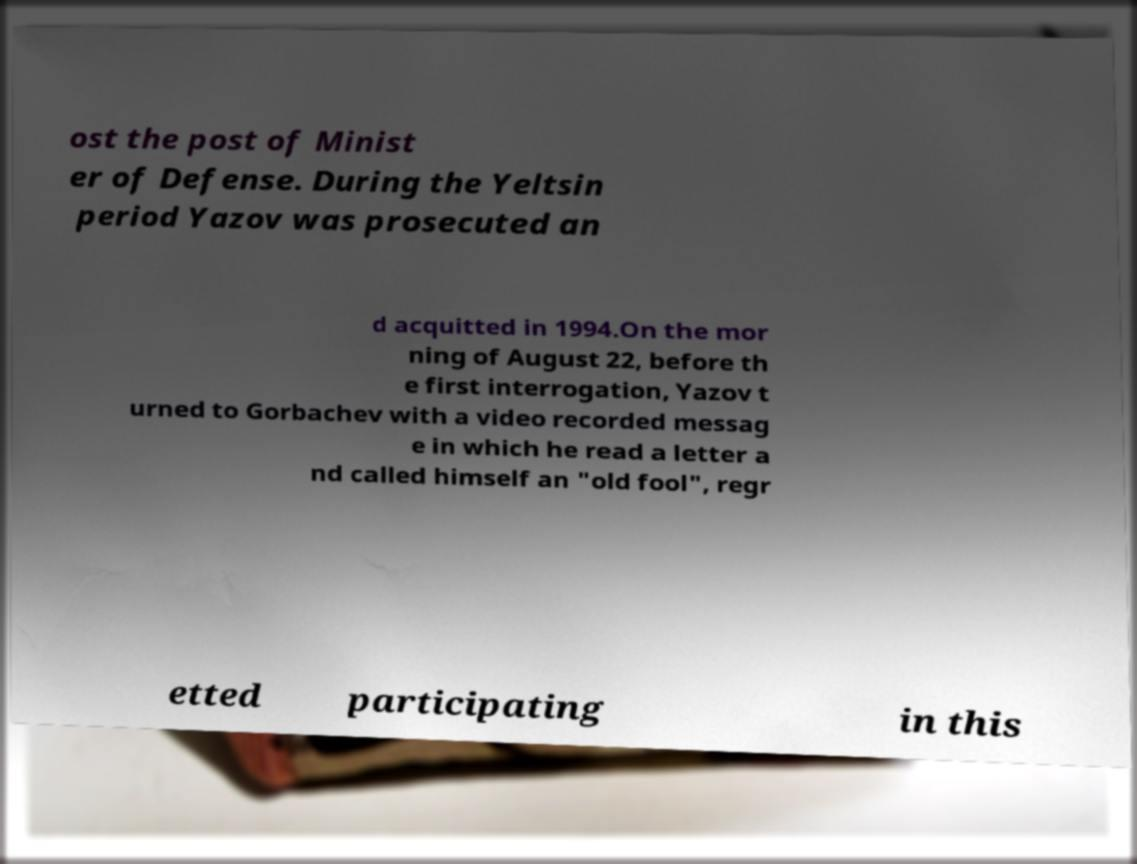There's text embedded in this image that I need extracted. Can you transcribe it verbatim? ost the post of Minist er of Defense. During the Yeltsin period Yazov was prosecuted an d acquitted in 1994.On the mor ning of August 22, before th e first interrogation, Yazov t urned to Gorbachev with a video recorded messag e in which he read a letter a nd called himself an "old fool", regr etted participating in this 